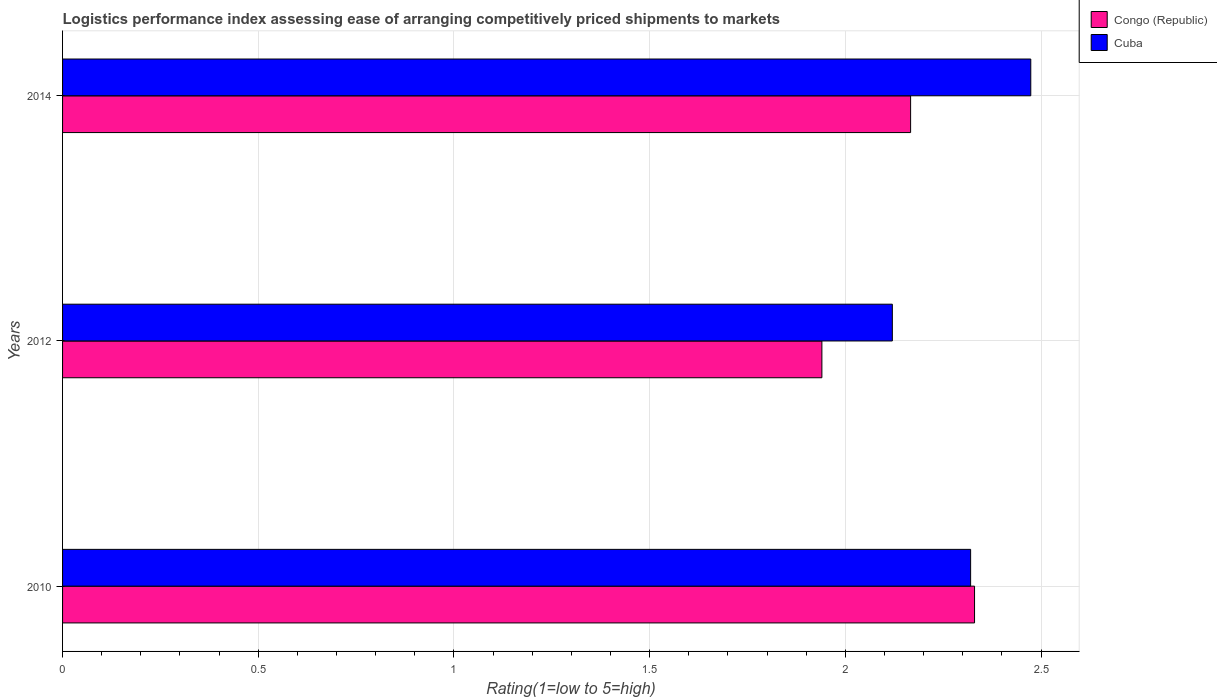How many groups of bars are there?
Ensure brevity in your answer.  3. Are the number of bars on each tick of the Y-axis equal?
Offer a very short reply. Yes. How many bars are there on the 2nd tick from the top?
Provide a short and direct response. 2. What is the label of the 3rd group of bars from the top?
Provide a succinct answer. 2010. What is the Logistic performance index in Congo (Republic) in 2014?
Make the answer very short. 2.17. Across all years, what is the maximum Logistic performance index in Cuba?
Your answer should be very brief. 2.47. Across all years, what is the minimum Logistic performance index in Cuba?
Your response must be concise. 2.12. In which year was the Logistic performance index in Cuba maximum?
Offer a very short reply. 2014. In which year was the Logistic performance index in Congo (Republic) minimum?
Your answer should be compact. 2012. What is the total Logistic performance index in Congo (Republic) in the graph?
Your response must be concise. 6.44. What is the difference between the Logistic performance index in Congo (Republic) in 2012 and that in 2014?
Offer a terse response. -0.23. What is the difference between the Logistic performance index in Congo (Republic) in 2014 and the Logistic performance index in Cuba in 2012?
Provide a succinct answer. 0.05. What is the average Logistic performance index in Cuba per year?
Provide a succinct answer. 2.3. In the year 2010, what is the difference between the Logistic performance index in Congo (Republic) and Logistic performance index in Cuba?
Keep it short and to the point. 0.01. In how many years, is the Logistic performance index in Congo (Republic) greater than 1.8 ?
Ensure brevity in your answer.  3. What is the ratio of the Logistic performance index in Cuba in 2010 to that in 2012?
Provide a succinct answer. 1.09. Is the Logistic performance index in Congo (Republic) in 2012 less than that in 2014?
Offer a very short reply. Yes. Is the difference between the Logistic performance index in Congo (Republic) in 2010 and 2014 greater than the difference between the Logistic performance index in Cuba in 2010 and 2014?
Offer a very short reply. Yes. What is the difference between the highest and the second highest Logistic performance index in Congo (Republic)?
Your answer should be compact. 0.16. What is the difference between the highest and the lowest Logistic performance index in Cuba?
Ensure brevity in your answer.  0.35. Is the sum of the Logistic performance index in Congo (Republic) in 2010 and 2012 greater than the maximum Logistic performance index in Cuba across all years?
Keep it short and to the point. Yes. What does the 2nd bar from the top in 2014 represents?
Make the answer very short. Congo (Republic). What does the 1st bar from the bottom in 2014 represents?
Your response must be concise. Congo (Republic). What is the difference between two consecutive major ticks on the X-axis?
Offer a very short reply. 0.5. Does the graph contain grids?
Your answer should be very brief. Yes. Where does the legend appear in the graph?
Ensure brevity in your answer.  Top right. How many legend labels are there?
Offer a very short reply. 2. What is the title of the graph?
Ensure brevity in your answer.  Logistics performance index assessing ease of arranging competitively priced shipments to markets. Does "Latin America(all income levels)" appear as one of the legend labels in the graph?
Give a very brief answer. No. What is the label or title of the X-axis?
Provide a succinct answer. Rating(1=low to 5=high). What is the label or title of the Y-axis?
Give a very brief answer. Years. What is the Rating(1=low to 5=high) in Congo (Republic) in 2010?
Your answer should be very brief. 2.33. What is the Rating(1=low to 5=high) of Cuba in 2010?
Offer a very short reply. 2.32. What is the Rating(1=low to 5=high) in Congo (Republic) in 2012?
Make the answer very short. 1.94. What is the Rating(1=low to 5=high) of Cuba in 2012?
Your answer should be very brief. 2.12. What is the Rating(1=low to 5=high) in Congo (Republic) in 2014?
Your answer should be compact. 2.17. What is the Rating(1=low to 5=high) in Cuba in 2014?
Your answer should be very brief. 2.47. Across all years, what is the maximum Rating(1=low to 5=high) of Congo (Republic)?
Your response must be concise. 2.33. Across all years, what is the maximum Rating(1=low to 5=high) in Cuba?
Offer a terse response. 2.47. Across all years, what is the minimum Rating(1=low to 5=high) in Congo (Republic)?
Offer a terse response. 1.94. Across all years, what is the minimum Rating(1=low to 5=high) of Cuba?
Make the answer very short. 2.12. What is the total Rating(1=low to 5=high) of Congo (Republic) in the graph?
Your answer should be compact. 6.44. What is the total Rating(1=low to 5=high) in Cuba in the graph?
Provide a short and direct response. 6.91. What is the difference between the Rating(1=low to 5=high) in Congo (Republic) in 2010 and that in 2012?
Keep it short and to the point. 0.39. What is the difference between the Rating(1=low to 5=high) of Congo (Republic) in 2010 and that in 2014?
Provide a succinct answer. 0.16. What is the difference between the Rating(1=low to 5=high) of Cuba in 2010 and that in 2014?
Your answer should be compact. -0.15. What is the difference between the Rating(1=low to 5=high) of Congo (Republic) in 2012 and that in 2014?
Offer a terse response. -0.23. What is the difference between the Rating(1=low to 5=high) in Cuba in 2012 and that in 2014?
Provide a short and direct response. -0.35. What is the difference between the Rating(1=low to 5=high) in Congo (Republic) in 2010 and the Rating(1=low to 5=high) in Cuba in 2012?
Offer a terse response. 0.21. What is the difference between the Rating(1=low to 5=high) of Congo (Republic) in 2010 and the Rating(1=low to 5=high) of Cuba in 2014?
Offer a very short reply. -0.14. What is the difference between the Rating(1=low to 5=high) in Congo (Republic) in 2012 and the Rating(1=low to 5=high) in Cuba in 2014?
Your response must be concise. -0.53. What is the average Rating(1=low to 5=high) of Congo (Republic) per year?
Your answer should be compact. 2.15. What is the average Rating(1=low to 5=high) of Cuba per year?
Keep it short and to the point. 2.3. In the year 2010, what is the difference between the Rating(1=low to 5=high) in Congo (Republic) and Rating(1=low to 5=high) in Cuba?
Your answer should be very brief. 0.01. In the year 2012, what is the difference between the Rating(1=low to 5=high) in Congo (Republic) and Rating(1=low to 5=high) in Cuba?
Offer a terse response. -0.18. In the year 2014, what is the difference between the Rating(1=low to 5=high) of Congo (Republic) and Rating(1=low to 5=high) of Cuba?
Offer a very short reply. -0.31. What is the ratio of the Rating(1=low to 5=high) of Congo (Republic) in 2010 to that in 2012?
Provide a short and direct response. 1.2. What is the ratio of the Rating(1=low to 5=high) of Cuba in 2010 to that in 2012?
Provide a short and direct response. 1.09. What is the ratio of the Rating(1=low to 5=high) of Congo (Republic) in 2010 to that in 2014?
Offer a terse response. 1.08. What is the ratio of the Rating(1=low to 5=high) in Cuba in 2010 to that in 2014?
Your answer should be very brief. 0.94. What is the ratio of the Rating(1=low to 5=high) in Congo (Republic) in 2012 to that in 2014?
Your answer should be very brief. 0.9. What is the ratio of the Rating(1=low to 5=high) of Cuba in 2012 to that in 2014?
Make the answer very short. 0.86. What is the difference between the highest and the second highest Rating(1=low to 5=high) of Congo (Republic)?
Keep it short and to the point. 0.16. What is the difference between the highest and the second highest Rating(1=low to 5=high) in Cuba?
Offer a very short reply. 0.15. What is the difference between the highest and the lowest Rating(1=low to 5=high) of Congo (Republic)?
Ensure brevity in your answer.  0.39. What is the difference between the highest and the lowest Rating(1=low to 5=high) in Cuba?
Offer a terse response. 0.35. 